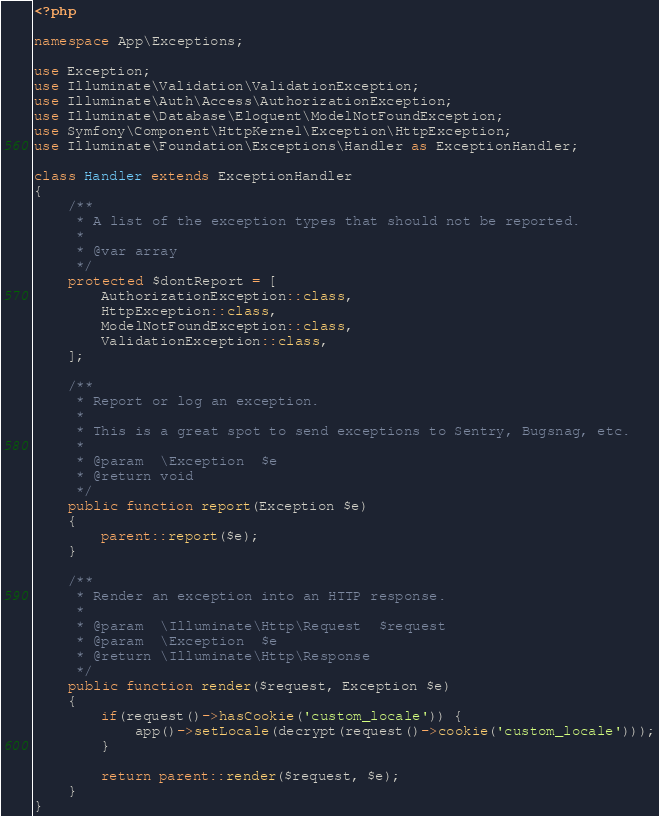Convert code to text. <code><loc_0><loc_0><loc_500><loc_500><_PHP_><?php

namespace App\Exceptions;

use Exception;
use Illuminate\Validation\ValidationException;
use Illuminate\Auth\Access\AuthorizationException;
use Illuminate\Database\Eloquent\ModelNotFoundException;
use Symfony\Component\HttpKernel\Exception\HttpException;
use Illuminate\Foundation\Exceptions\Handler as ExceptionHandler;

class Handler extends ExceptionHandler
{
    /**
     * A list of the exception types that should not be reported.
     *
     * @var array
     */
    protected $dontReport = [
        AuthorizationException::class,
        HttpException::class,
        ModelNotFoundException::class,
        ValidationException::class,
    ];

    /**
     * Report or log an exception.
     *
     * This is a great spot to send exceptions to Sentry, Bugsnag, etc.
     *
     * @param  \Exception  $e
     * @return void
     */
    public function report(Exception $e)
    {
        parent::report($e);
    }

    /**
     * Render an exception into an HTTP response.
     *
     * @param  \Illuminate\Http\Request  $request
     * @param  \Exception  $e
     * @return \Illuminate\Http\Response
     */
    public function render($request, Exception $e)
    {
        if(request()->hasCookie('custom_locale')) {
            app()->setLocale(decrypt(request()->cookie('custom_locale')));
        }

        return parent::render($request, $e);
    }
}
</code> 